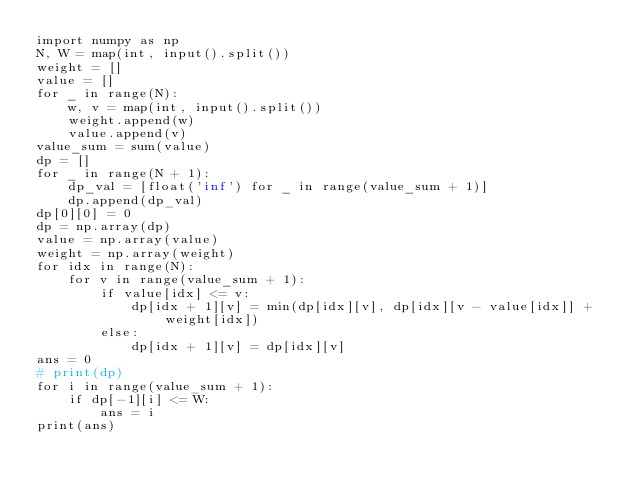Convert code to text. <code><loc_0><loc_0><loc_500><loc_500><_Python_>import numpy as np
N, W = map(int, input().split())
weight = []
value = []
for _ in range(N):
    w, v = map(int, input().split())
    weight.append(w)
    value.append(v)
value_sum = sum(value)
dp = []
for _ in range(N + 1):
    dp_val = [float('inf') for _ in range(value_sum + 1)]
    dp.append(dp_val)
dp[0][0] = 0
dp = np.array(dp)
value = np.array(value)
weight = np.array(weight)
for idx in range(N):
    for v in range(value_sum + 1):
        if value[idx] <= v:
            dp[idx + 1][v] = min(dp[idx][v], dp[idx][v - value[idx]] + weight[idx])
        else:
            dp[idx + 1][v] = dp[idx][v]
ans = 0
# print(dp)
for i in range(value_sum + 1):
    if dp[-1][i] <= W:
        ans = i
print(ans)</code> 